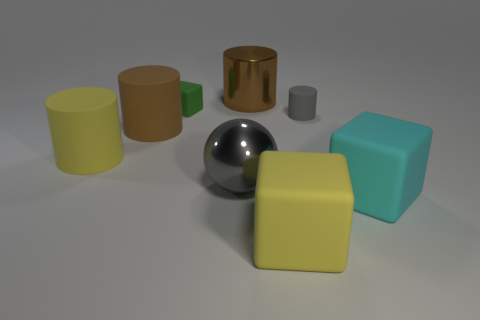Subtract 1 cylinders. How many cylinders are left? 3 Add 1 green things. How many objects exist? 9 Subtract all balls. How many objects are left? 7 Add 5 small gray matte objects. How many small gray matte objects exist? 6 Subtract 1 yellow cubes. How many objects are left? 7 Subtract all large brown rubber cylinders. Subtract all tiny yellow matte blocks. How many objects are left? 7 Add 1 shiny cylinders. How many shiny cylinders are left? 2 